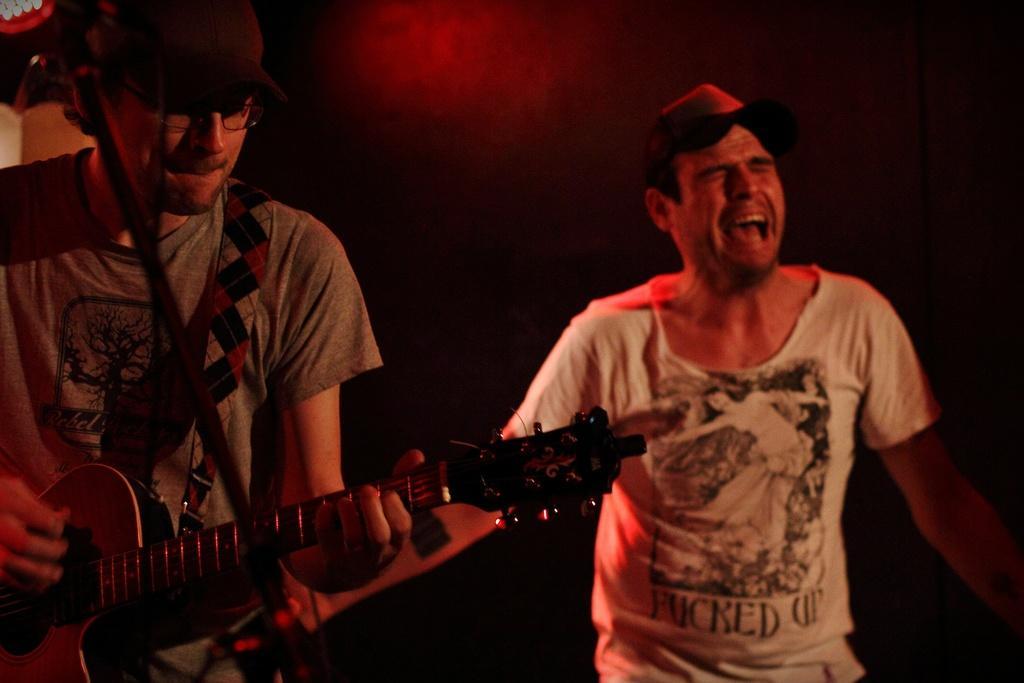Describe this image in one or two sentences. In the image we can see there is a man who is holding a guitar in his hand and beside him there is a man who is wearing a cap. 